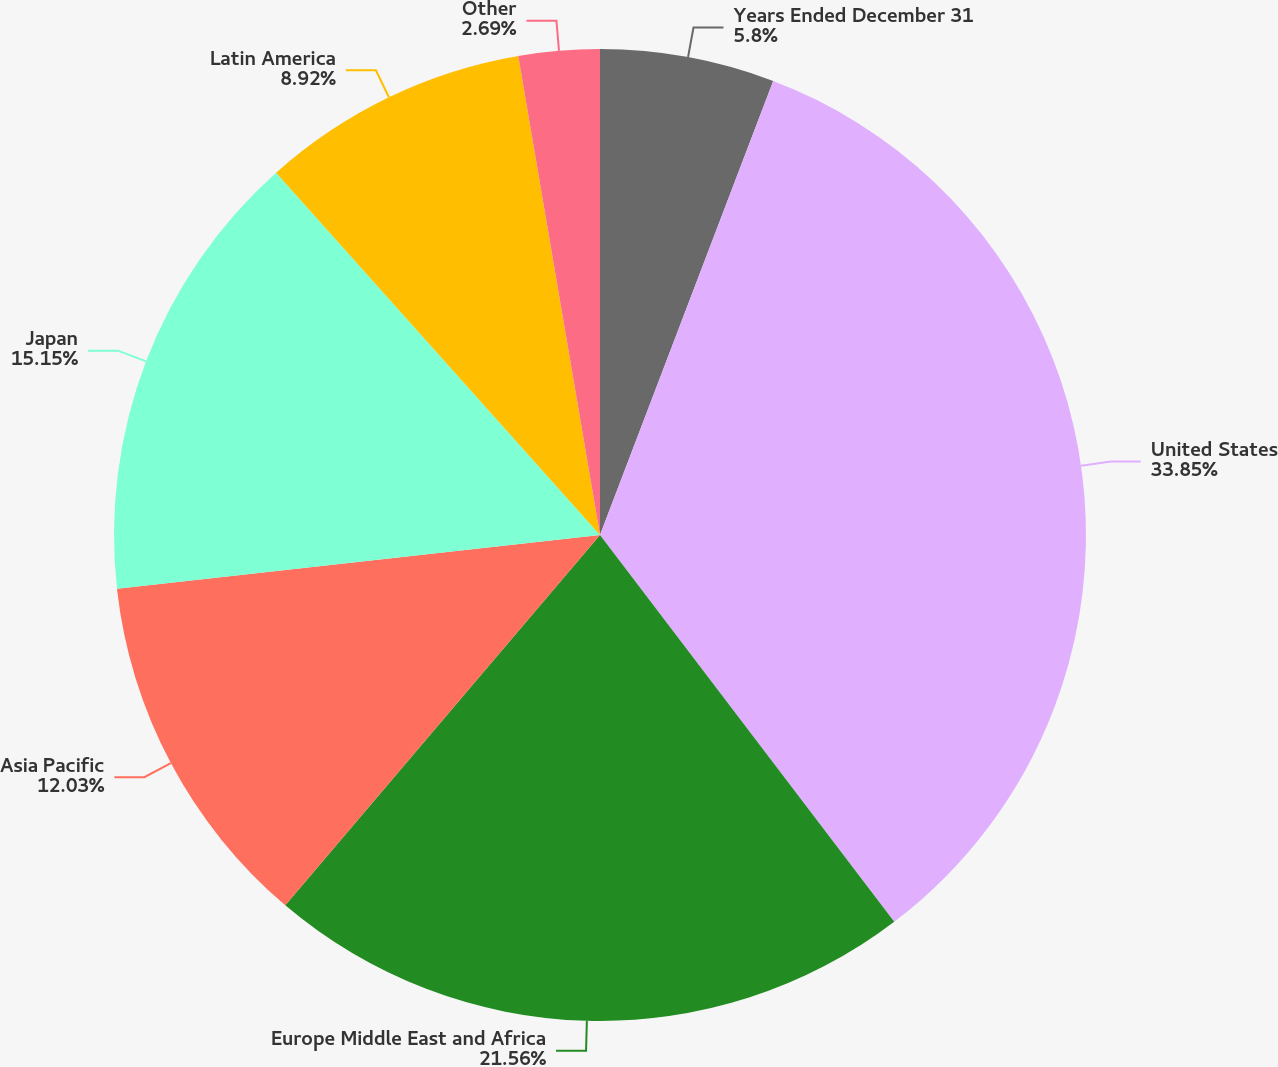<chart> <loc_0><loc_0><loc_500><loc_500><pie_chart><fcel>Years Ended December 31<fcel>United States<fcel>Europe Middle East and Africa<fcel>Asia Pacific<fcel>Japan<fcel>Latin America<fcel>Other<nl><fcel>5.8%<fcel>33.85%<fcel>21.56%<fcel>12.03%<fcel>15.15%<fcel>8.92%<fcel>2.69%<nl></chart> 